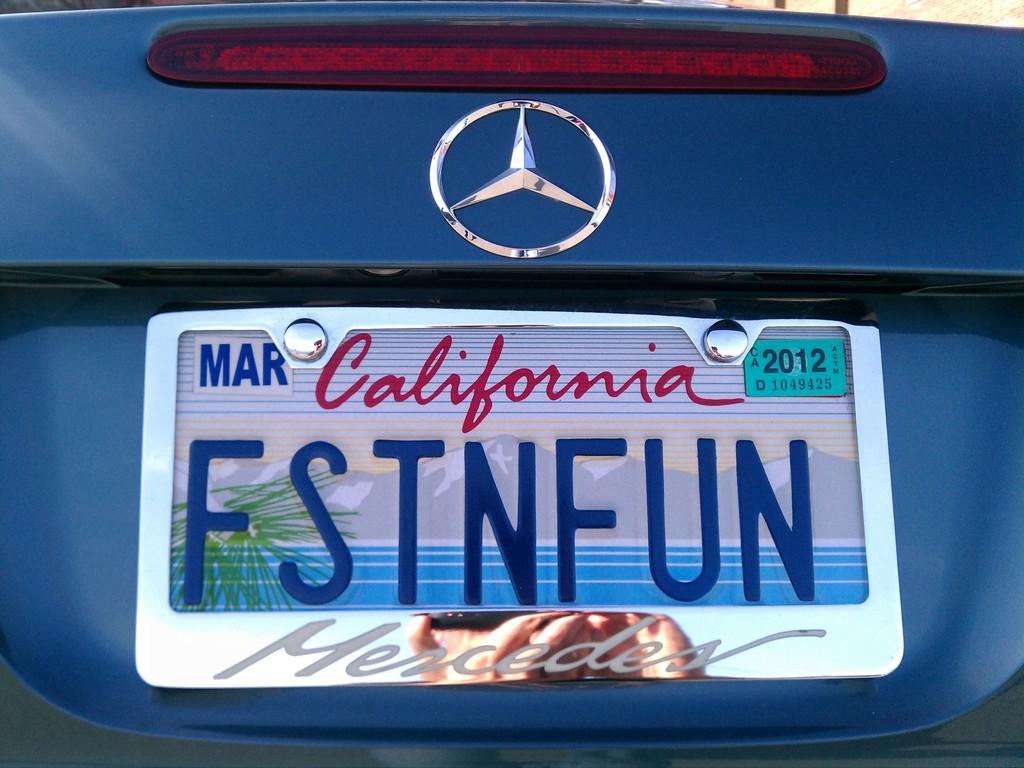Where was this cars licenses plate issues?
Your response must be concise. California. What is the brand of the license plate cover?
Your answer should be very brief. Mercedes. 